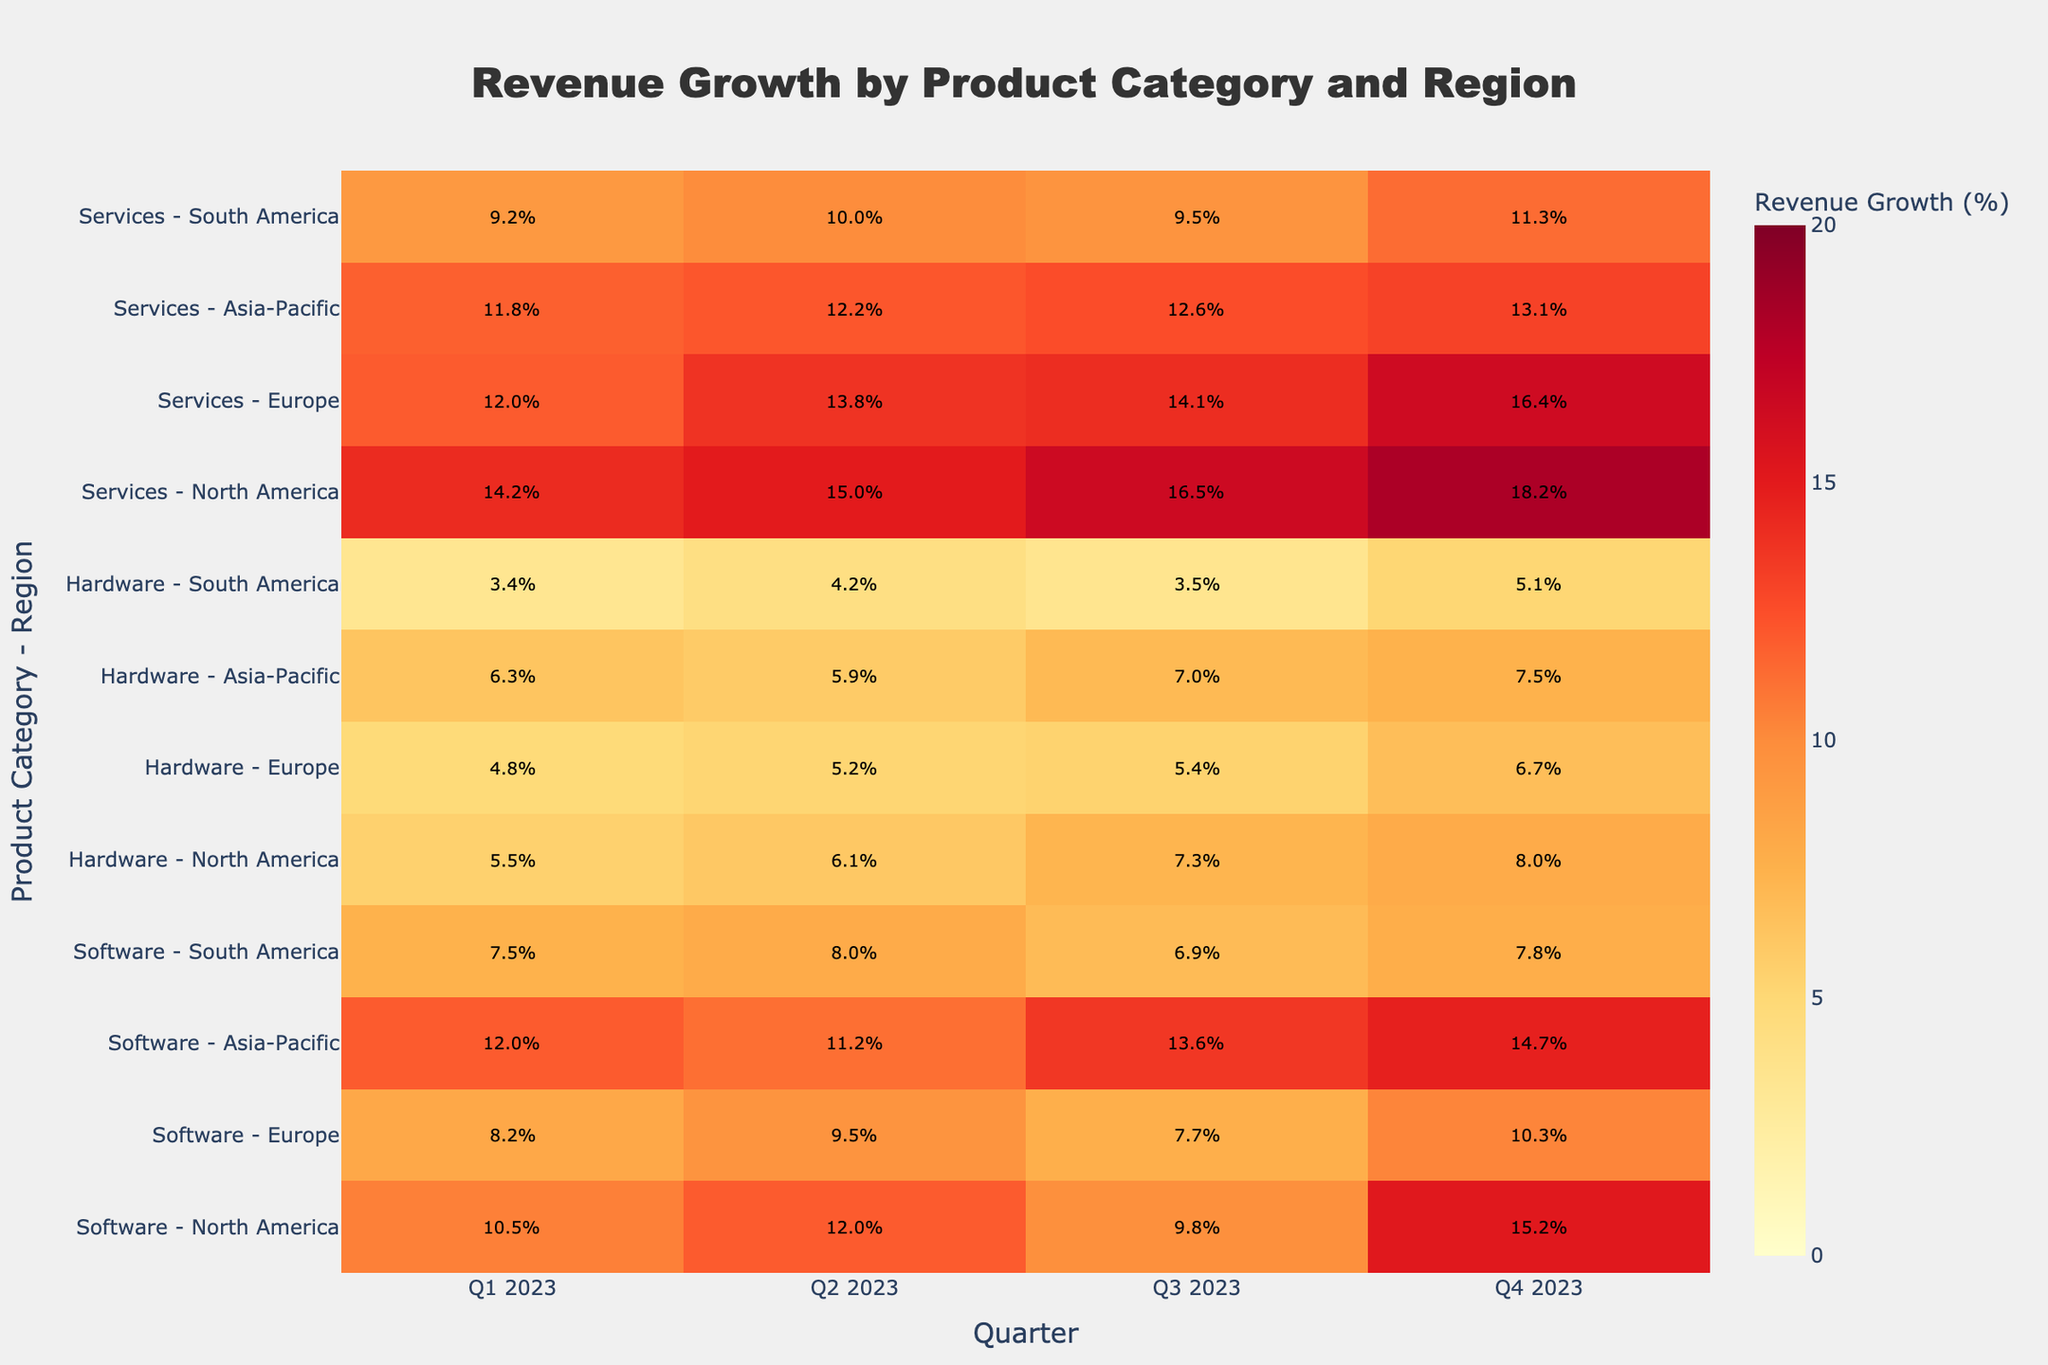What's the title of the heatmap? The title of the heatmap is displayed prominently at the top of the figure.
Answer: Revenue Growth by Product Category and Region What are the regions displayed in the heatmap? The regions are listed on the y-axis labels in combination with the product categories. They are North America, Europe, Asia-Pacific, and South America.
Answer: North America, Europe, Asia-Pacific, South America Which product category and region combination had the highest revenue growth in Q4 2023? By examining the highest value in Q4 2023, the combination with the largest percentage is found. "Services - North America" has the highest value of 18.2%.
Answer: Services - North America How does the revenue growth of "Hardware - North America" change from Q1 2023 to Q4 2023? To understand the change, observe the values for "Hardware - North America" across Q1 to Q4. The values are 5.5%, 6.1%, 7.3%, and 8.0%, showing a continuous increase.
Answer: It continuously increases Which product category had the most consistent revenue growth across all regions in 2023? Assessing the consistency involves looking at the variations within each product category across different quarters and regions. "Software" shows relatively small variations across all regions and quarters compared to others.
Answer: Software What is the average revenue growth for "Software - Asia-Pacific" across all quarters in 2023? Calculate the average by summing values and dividing by the number of quarters: (12.0 + 11.2 + 13.6 + 14.7) / 4 = 12.875.
Answer: 12.875% Compare the revenue growth between "Services - Europe" and "Software - Europe" in Q2 2023. Which one is higher? Compare the Q2 2023 values for both combinations. "Services - Europe" has 13.8%, and "Software - Europe" has 9.5%. "Services - Europe" is higher.
Answer: Services - Europe What is the difference in revenue growth between "Hardware - South America" and "Software - South America" in Q3 2023? Subtract the values: "Software - South America" (6.9%) - "Hardware - South America" (3.5%) = 3.4%.
Answer: 3.4% Which quarter had the highest total revenue growth for “Services” across all regions? Sum the quarter values for services across all regions for each quarter and compare. Q4 2023 has the highest total (18.2 + 16.4 + 13.1 + 11.3 = 59.0%).
Answer: Q4 2023 What patterns can be observed in the revenue growth for "Hardware" across different regions in 2023? Observe trends in each region for "Hardware." There's an overall increase in revenue growth from Q1 to Q4, with notable differences: North America increases steadily, while South America shows more variability.
Answer: Increasing trend, variability in South America 